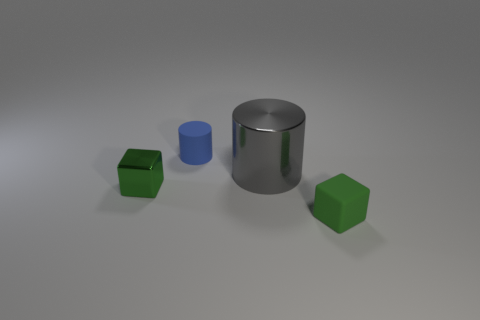Add 4 blue metallic cylinders. How many objects exist? 8 Subtract all blue metallic spheres. Subtract all small blue objects. How many objects are left? 3 Add 3 green metallic blocks. How many green metallic blocks are left? 4 Add 4 large yellow metallic spheres. How many large yellow metallic spheres exist? 4 Subtract 1 gray cylinders. How many objects are left? 3 